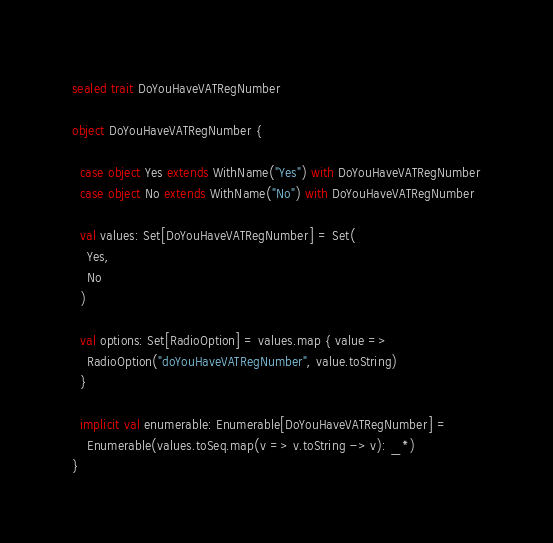<code> <loc_0><loc_0><loc_500><loc_500><_Scala_>sealed trait DoYouHaveVATRegNumber

object DoYouHaveVATRegNumber {

  case object Yes extends WithName("Yes") with DoYouHaveVATRegNumber
  case object No extends WithName("No") with DoYouHaveVATRegNumber

  val values: Set[DoYouHaveVATRegNumber] = Set(
    Yes,
    No
  )

  val options: Set[RadioOption] = values.map { value =>
    RadioOption("doYouHaveVATRegNumber", value.toString)
  }

  implicit val enumerable: Enumerable[DoYouHaveVATRegNumber] =
    Enumerable(values.toSeq.map(v => v.toString -> v): _*)
}
</code> 